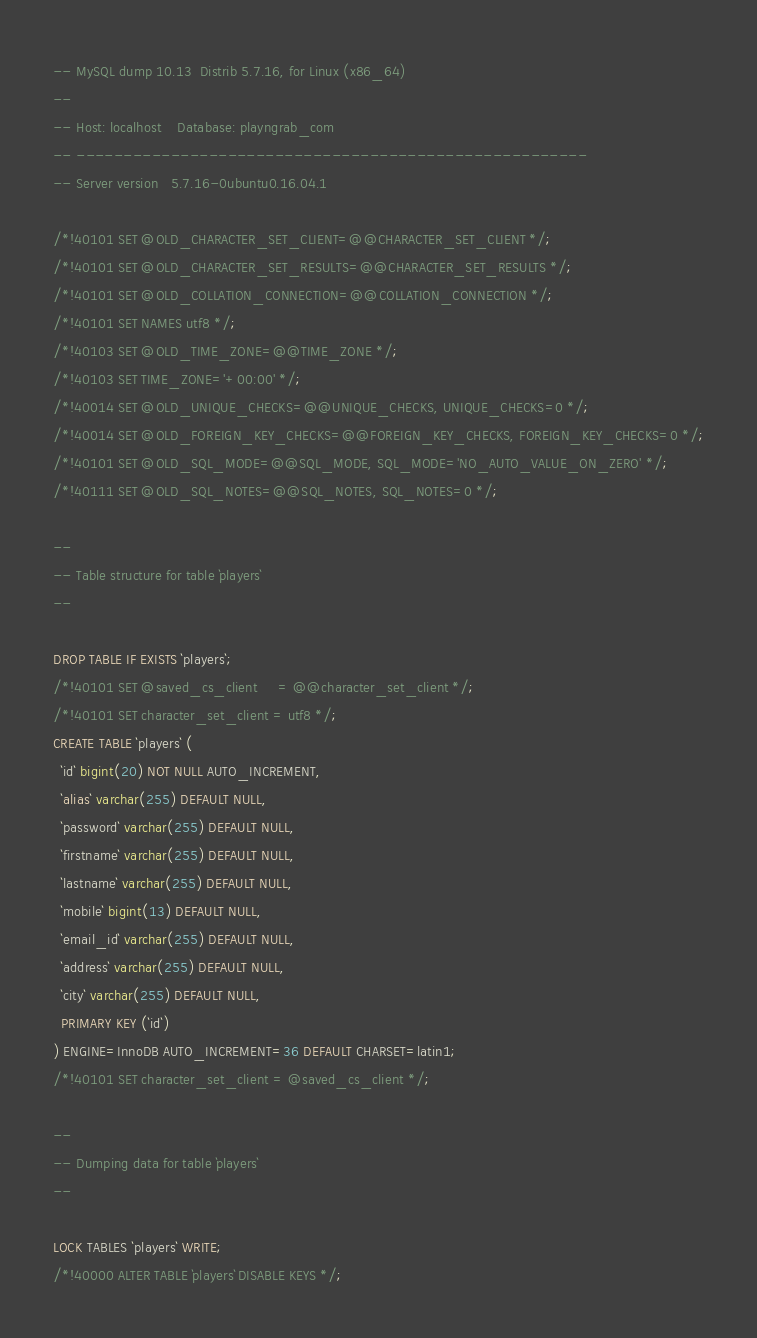<code> <loc_0><loc_0><loc_500><loc_500><_SQL_>-- MySQL dump 10.13  Distrib 5.7.16, for Linux (x86_64)
--
-- Host: localhost    Database: playngrab_com
-- ------------------------------------------------------
-- Server version	5.7.16-0ubuntu0.16.04.1

/*!40101 SET @OLD_CHARACTER_SET_CLIENT=@@CHARACTER_SET_CLIENT */;
/*!40101 SET @OLD_CHARACTER_SET_RESULTS=@@CHARACTER_SET_RESULTS */;
/*!40101 SET @OLD_COLLATION_CONNECTION=@@COLLATION_CONNECTION */;
/*!40101 SET NAMES utf8 */;
/*!40103 SET @OLD_TIME_ZONE=@@TIME_ZONE */;
/*!40103 SET TIME_ZONE='+00:00' */;
/*!40014 SET @OLD_UNIQUE_CHECKS=@@UNIQUE_CHECKS, UNIQUE_CHECKS=0 */;
/*!40014 SET @OLD_FOREIGN_KEY_CHECKS=@@FOREIGN_KEY_CHECKS, FOREIGN_KEY_CHECKS=0 */;
/*!40101 SET @OLD_SQL_MODE=@@SQL_MODE, SQL_MODE='NO_AUTO_VALUE_ON_ZERO' */;
/*!40111 SET @OLD_SQL_NOTES=@@SQL_NOTES, SQL_NOTES=0 */;

--
-- Table structure for table `players`
--

DROP TABLE IF EXISTS `players`;
/*!40101 SET @saved_cs_client     = @@character_set_client */;
/*!40101 SET character_set_client = utf8 */;
CREATE TABLE `players` (
  `id` bigint(20) NOT NULL AUTO_INCREMENT,
  `alias` varchar(255) DEFAULT NULL,
  `password` varchar(255) DEFAULT NULL,
  `firstname` varchar(255) DEFAULT NULL,
  `lastname` varchar(255) DEFAULT NULL,
  `mobile` bigint(13) DEFAULT NULL,
  `email_id` varchar(255) DEFAULT NULL,
  `address` varchar(255) DEFAULT NULL,
  `city` varchar(255) DEFAULT NULL,
  PRIMARY KEY (`id`)
) ENGINE=InnoDB AUTO_INCREMENT=36 DEFAULT CHARSET=latin1;
/*!40101 SET character_set_client = @saved_cs_client */;

--
-- Dumping data for table `players`
--

LOCK TABLES `players` WRITE;
/*!40000 ALTER TABLE `players` DISABLE KEYS */;</code> 